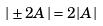Convert formula to latex. <formula><loc_0><loc_0><loc_500><loc_500>| \pm 2 A | = 2 | A |</formula> 